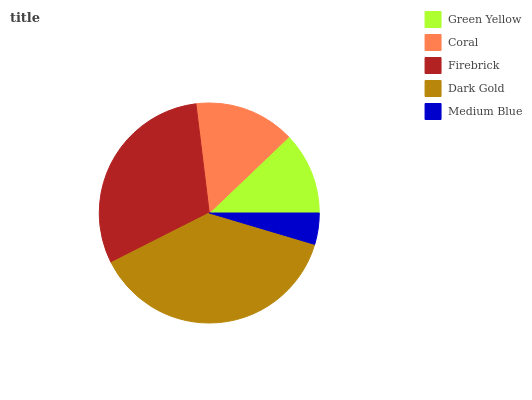Is Medium Blue the minimum?
Answer yes or no. Yes. Is Dark Gold the maximum?
Answer yes or no. Yes. Is Coral the minimum?
Answer yes or no. No. Is Coral the maximum?
Answer yes or no. No. Is Coral greater than Green Yellow?
Answer yes or no. Yes. Is Green Yellow less than Coral?
Answer yes or no. Yes. Is Green Yellow greater than Coral?
Answer yes or no. No. Is Coral less than Green Yellow?
Answer yes or no. No. Is Coral the high median?
Answer yes or no. Yes. Is Coral the low median?
Answer yes or no. Yes. Is Dark Gold the high median?
Answer yes or no. No. Is Firebrick the low median?
Answer yes or no. No. 